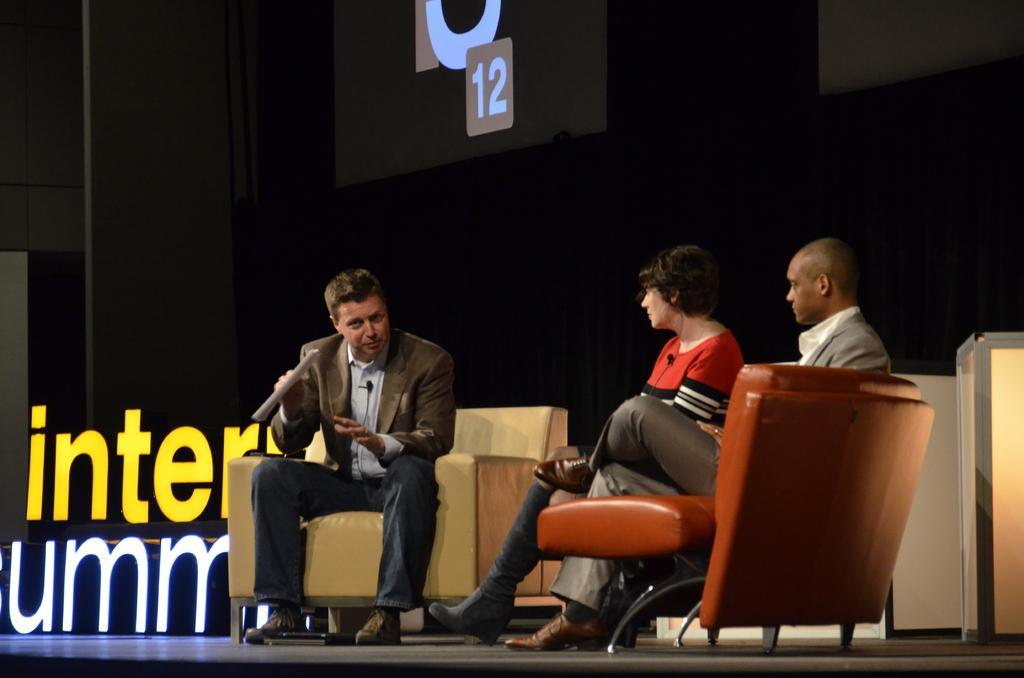Describe this image in one or two sentences. In the given image we can see that there are three persons sitting on sofa. Right side there are two persons and left side there is on person. 